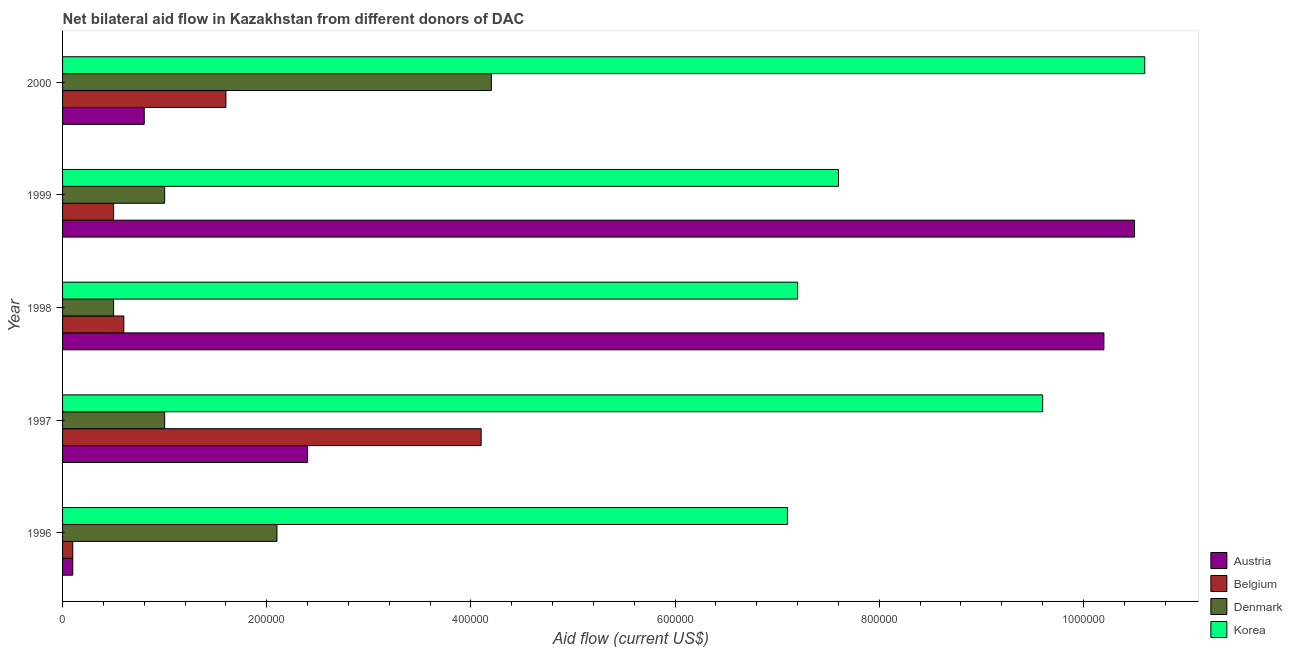How many groups of bars are there?
Offer a terse response. 5. In how many cases, is the number of bars for a given year not equal to the number of legend labels?
Offer a terse response. 0. What is the amount of aid given by denmark in 1996?
Offer a very short reply. 2.10e+05. Across all years, what is the maximum amount of aid given by denmark?
Make the answer very short. 4.20e+05. Across all years, what is the minimum amount of aid given by korea?
Your answer should be very brief. 7.10e+05. In which year was the amount of aid given by denmark maximum?
Provide a succinct answer. 2000. What is the total amount of aid given by austria in the graph?
Provide a succinct answer. 2.40e+06. What is the difference between the amount of aid given by austria in 1996 and that in 1997?
Give a very brief answer. -2.30e+05. What is the difference between the amount of aid given by denmark in 1997 and the amount of aid given by belgium in 2000?
Give a very brief answer. -6.00e+04. What is the average amount of aid given by belgium per year?
Provide a short and direct response. 1.38e+05. In the year 1998, what is the difference between the amount of aid given by denmark and amount of aid given by korea?
Ensure brevity in your answer.  -6.70e+05. What is the ratio of the amount of aid given by denmark in 1996 to that in 1999?
Your response must be concise. 2.1. Is the difference between the amount of aid given by belgium in 1997 and 2000 greater than the difference between the amount of aid given by korea in 1997 and 2000?
Keep it short and to the point. Yes. What is the difference between the highest and the lowest amount of aid given by belgium?
Your answer should be very brief. 4.00e+05. In how many years, is the amount of aid given by korea greater than the average amount of aid given by korea taken over all years?
Provide a short and direct response. 2. Is the sum of the amount of aid given by belgium in 1996 and 1999 greater than the maximum amount of aid given by denmark across all years?
Make the answer very short. No. What does the 2nd bar from the top in 1997 represents?
Make the answer very short. Denmark. What does the 4th bar from the bottom in 1999 represents?
Your response must be concise. Korea. How many years are there in the graph?
Offer a very short reply. 5. Are the values on the major ticks of X-axis written in scientific E-notation?
Offer a very short reply. No. Where does the legend appear in the graph?
Your answer should be very brief. Bottom right. How are the legend labels stacked?
Your answer should be very brief. Vertical. What is the title of the graph?
Keep it short and to the point. Net bilateral aid flow in Kazakhstan from different donors of DAC. Does "UNHCR" appear as one of the legend labels in the graph?
Your response must be concise. No. What is the Aid flow (current US$) in Denmark in 1996?
Keep it short and to the point. 2.10e+05. What is the Aid flow (current US$) in Korea in 1996?
Your response must be concise. 7.10e+05. What is the Aid flow (current US$) in Austria in 1997?
Provide a short and direct response. 2.40e+05. What is the Aid flow (current US$) of Denmark in 1997?
Offer a very short reply. 1.00e+05. What is the Aid flow (current US$) of Korea in 1997?
Make the answer very short. 9.60e+05. What is the Aid flow (current US$) in Austria in 1998?
Provide a short and direct response. 1.02e+06. What is the Aid flow (current US$) of Belgium in 1998?
Keep it short and to the point. 6.00e+04. What is the Aid flow (current US$) of Denmark in 1998?
Make the answer very short. 5.00e+04. What is the Aid flow (current US$) in Korea in 1998?
Your response must be concise. 7.20e+05. What is the Aid flow (current US$) of Austria in 1999?
Give a very brief answer. 1.05e+06. What is the Aid flow (current US$) of Belgium in 1999?
Make the answer very short. 5.00e+04. What is the Aid flow (current US$) of Korea in 1999?
Provide a short and direct response. 7.60e+05. What is the Aid flow (current US$) in Austria in 2000?
Your response must be concise. 8.00e+04. What is the Aid flow (current US$) of Denmark in 2000?
Provide a short and direct response. 4.20e+05. What is the Aid flow (current US$) in Korea in 2000?
Offer a very short reply. 1.06e+06. Across all years, what is the maximum Aid flow (current US$) of Austria?
Your answer should be very brief. 1.05e+06. Across all years, what is the maximum Aid flow (current US$) in Denmark?
Provide a short and direct response. 4.20e+05. Across all years, what is the maximum Aid flow (current US$) of Korea?
Your response must be concise. 1.06e+06. Across all years, what is the minimum Aid flow (current US$) of Denmark?
Ensure brevity in your answer.  5.00e+04. Across all years, what is the minimum Aid flow (current US$) in Korea?
Give a very brief answer. 7.10e+05. What is the total Aid flow (current US$) in Austria in the graph?
Provide a short and direct response. 2.40e+06. What is the total Aid flow (current US$) of Belgium in the graph?
Offer a terse response. 6.90e+05. What is the total Aid flow (current US$) of Denmark in the graph?
Keep it short and to the point. 8.80e+05. What is the total Aid flow (current US$) in Korea in the graph?
Keep it short and to the point. 4.21e+06. What is the difference between the Aid flow (current US$) of Belgium in 1996 and that in 1997?
Provide a succinct answer. -4.00e+05. What is the difference between the Aid flow (current US$) of Denmark in 1996 and that in 1997?
Your answer should be compact. 1.10e+05. What is the difference between the Aid flow (current US$) in Korea in 1996 and that in 1997?
Give a very brief answer. -2.50e+05. What is the difference between the Aid flow (current US$) of Austria in 1996 and that in 1998?
Make the answer very short. -1.01e+06. What is the difference between the Aid flow (current US$) of Belgium in 1996 and that in 1998?
Your response must be concise. -5.00e+04. What is the difference between the Aid flow (current US$) of Korea in 1996 and that in 1998?
Provide a succinct answer. -10000. What is the difference between the Aid flow (current US$) of Austria in 1996 and that in 1999?
Ensure brevity in your answer.  -1.04e+06. What is the difference between the Aid flow (current US$) in Belgium in 1996 and that in 1999?
Your answer should be compact. -4.00e+04. What is the difference between the Aid flow (current US$) in Korea in 1996 and that in 1999?
Give a very brief answer. -5.00e+04. What is the difference between the Aid flow (current US$) in Denmark in 1996 and that in 2000?
Give a very brief answer. -2.10e+05. What is the difference between the Aid flow (current US$) of Korea in 1996 and that in 2000?
Keep it short and to the point. -3.50e+05. What is the difference between the Aid flow (current US$) of Austria in 1997 and that in 1998?
Ensure brevity in your answer.  -7.80e+05. What is the difference between the Aid flow (current US$) of Belgium in 1997 and that in 1998?
Make the answer very short. 3.50e+05. What is the difference between the Aid flow (current US$) of Denmark in 1997 and that in 1998?
Keep it short and to the point. 5.00e+04. What is the difference between the Aid flow (current US$) of Austria in 1997 and that in 1999?
Your answer should be very brief. -8.10e+05. What is the difference between the Aid flow (current US$) in Belgium in 1997 and that in 1999?
Provide a succinct answer. 3.60e+05. What is the difference between the Aid flow (current US$) of Denmark in 1997 and that in 1999?
Give a very brief answer. 0. What is the difference between the Aid flow (current US$) in Korea in 1997 and that in 1999?
Give a very brief answer. 2.00e+05. What is the difference between the Aid flow (current US$) of Belgium in 1997 and that in 2000?
Your answer should be compact. 2.50e+05. What is the difference between the Aid flow (current US$) of Denmark in 1997 and that in 2000?
Your answer should be very brief. -3.20e+05. What is the difference between the Aid flow (current US$) in Korea in 1997 and that in 2000?
Keep it short and to the point. -1.00e+05. What is the difference between the Aid flow (current US$) in Korea in 1998 and that in 1999?
Ensure brevity in your answer.  -4.00e+04. What is the difference between the Aid flow (current US$) of Austria in 1998 and that in 2000?
Offer a very short reply. 9.40e+05. What is the difference between the Aid flow (current US$) in Belgium in 1998 and that in 2000?
Your answer should be compact. -1.00e+05. What is the difference between the Aid flow (current US$) in Denmark in 1998 and that in 2000?
Your response must be concise. -3.70e+05. What is the difference between the Aid flow (current US$) in Austria in 1999 and that in 2000?
Your answer should be compact. 9.70e+05. What is the difference between the Aid flow (current US$) in Denmark in 1999 and that in 2000?
Your response must be concise. -3.20e+05. What is the difference between the Aid flow (current US$) in Austria in 1996 and the Aid flow (current US$) in Belgium in 1997?
Your answer should be compact. -4.00e+05. What is the difference between the Aid flow (current US$) of Austria in 1996 and the Aid flow (current US$) of Korea in 1997?
Offer a very short reply. -9.50e+05. What is the difference between the Aid flow (current US$) in Belgium in 1996 and the Aid flow (current US$) in Denmark in 1997?
Offer a terse response. -9.00e+04. What is the difference between the Aid flow (current US$) in Belgium in 1996 and the Aid flow (current US$) in Korea in 1997?
Ensure brevity in your answer.  -9.50e+05. What is the difference between the Aid flow (current US$) in Denmark in 1996 and the Aid flow (current US$) in Korea in 1997?
Your response must be concise. -7.50e+05. What is the difference between the Aid flow (current US$) in Austria in 1996 and the Aid flow (current US$) in Korea in 1998?
Your answer should be very brief. -7.10e+05. What is the difference between the Aid flow (current US$) in Belgium in 1996 and the Aid flow (current US$) in Denmark in 1998?
Make the answer very short. -4.00e+04. What is the difference between the Aid flow (current US$) in Belgium in 1996 and the Aid flow (current US$) in Korea in 1998?
Offer a terse response. -7.10e+05. What is the difference between the Aid flow (current US$) in Denmark in 1996 and the Aid flow (current US$) in Korea in 1998?
Offer a terse response. -5.10e+05. What is the difference between the Aid flow (current US$) in Austria in 1996 and the Aid flow (current US$) in Korea in 1999?
Your answer should be compact. -7.50e+05. What is the difference between the Aid flow (current US$) in Belgium in 1996 and the Aid flow (current US$) in Denmark in 1999?
Provide a succinct answer. -9.00e+04. What is the difference between the Aid flow (current US$) of Belgium in 1996 and the Aid flow (current US$) of Korea in 1999?
Your response must be concise. -7.50e+05. What is the difference between the Aid flow (current US$) of Denmark in 1996 and the Aid flow (current US$) of Korea in 1999?
Ensure brevity in your answer.  -5.50e+05. What is the difference between the Aid flow (current US$) in Austria in 1996 and the Aid flow (current US$) in Belgium in 2000?
Provide a succinct answer. -1.50e+05. What is the difference between the Aid flow (current US$) of Austria in 1996 and the Aid flow (current US$) of Denmark in 2000?
Offer a very short reply. -4.10e+05. What is the difference between the Aid flow (current US$) in Austria in 1996 and the Aid flow (current US$) in Korea in 2000?
Your answer should be compact. -1.05e+06. What is the difference between the Aid flow (current US$) in Belgium in 1996 and the Aid flow (current US$) in Denmark in 2000?
Make the answer very short. -4.10e+05. What is the difference between the Aid flow (current US$) in Belgium in 1996 and the Aid flow (current US$) in Korea in 2000?
Keep it short and to the point. -1.05e+06. What is the difference between the Aid flow (current US$) of Denmark in 1996 and the Aid flow (current US$) of Korea in 2000?
Keep it short and to the point. -8.50e+05. What is the difference between the Aid flow (current US$) of Austria in 1997 and the Aid flow (current US$) of Belgium in 1998?
Offer a terse response. 1.80e+05. What is the difference between the Aid flow (current US$) of Austria in 1997 and the Aid flow (current US$) of Korea in 1998?
Provide a succinct answer. -4.80e+05. What is the difference between the Aid flow (current US$) in Belgium in 1997 and the Aid flow (current US$) in Korea in 1998?
Your response must be concise. -3.10e+05. What is the difference between the Aid flow (current US$) in Denmark in 1997 and the Aid flow (current US$) in Korea in 1998?
Ensure brevity in your answer.  -6.20e+05. What is the difference between the Aid flow (current US$) of Austria in 1997 and the Aid flow (current US$) of Korea in 1999?
Keep it short and to the point. -5.20e+05. What is the difference between the Aid flow (current US$) in Belgium in 1997 and the Aid flow (current US$) in Denmark in 1999?
Your answer should be very brief. 3.10e+05. What is the difference between the Aid flow (current US$) of Belgium in 1997 and the Aid flow (current US$) of Korea in 1999?
Keep it short and to the point. -3.50e+05. What is the difference between the Aid flow (current US$) of Denmark in 1997 and the Aid flow (current US$) of Korea in 1999?
Offer a terse response. -6.60e+05. What is the difference between the Aid flow (current US$) of Austria in 1997 and the Aid flow (current US$) of Belgium in 2000?
Offer a terse response. 8.00e+04. What is the difference between the Aid flow (current US$) in Austria in 1997 and the Aid flow (current US$) in Denmark in 2000?
Your response must be concise. -1.80e+05. What is the difference between the Aid flow (current US$) in Austria in 1997 and the Aid flow (current US$) in Korea in 2000?
Keep it short and to the point. -8.20e+05. What is the difference between the Aid flow (current US$) of Belgium in 1997 and the Aid flow (current US$) of Denmark in 2000?
Your answer should be compact. -10000. What is the difference between the Aid flow (current US$) of Belgium in 1997 and the Aid flow (current US$) of Korea in 2000?
Keep it short and to the point. -6.50e+05. What is the difference between the Aid flow (current US$) of Denmark in 1997 and the Aid flow (current US$) of Korea in 2000?
Your answer should be very brief. -9.60e+05. What is the difference between the Aid flow (current US$) of Austria in 1998 and the Aid flow (current US$) of Belgium in 1999?
Provide a succinct answer. 9.70e+05. What is the difference between the Aid flow (current US$) in Austria in 1998 and the Aid flow (current US$) in Denmark in 1999?
Offer a terse response. 9.20e+05. What is the difference between the Aid flow (current US$) of Austria in 1998 and the Aid flow (current US$) of Korea in 1999?
Keep it short and to the point. 2.60e+05. What is the difference between the Aid flow (current US$) of Belgium in 1998 and the Aid flow (current US$) of Denmark in 1999?
Make the answer very short. -4.00e+04. What is the difference between the Aid flow (current US$) in Belgium in 1998 and the Aid flow (current US$) in Korea in 1999?
Keep it short and to the point. -7.00e+05. What is the difference between the Aid flow (current US$) of Denmark in 1998 and the Aid flow (current US$) of Korea in 1999?
Give a very brief answer. -7.10e+05. What is the difference between the Aid flow (current US$) in Austria in 1998 and the Aid flow (current US$) in Belgium in 2000?
Your answer should be compact. 8.60e+05. What is the difference between the Aid flow (current US$) in Austria in 1998 and the Aid flow (current US$) in Denmark in 2000?
Keep it short and to the point. 6.00e+05. What is the difference between the Aid flow (current US$) in Austria in 1998 and the Aid flow (current US$) in Korea in 2000?
Your response must be concise. -4.00e+04. What is the difference between the Aid flow (current US$) of Belgium in 1998 and the Aid flow (current US$) of Denmark in 2000?
Make the answer very short. -3.60e+05. What is the difference between the Aid flow (current US$) of Belgium in 1998 and the Aid flow (current US$) of Korea in 2000?
Offer a very short reply. -1.00e+06. What is the difference between the Aid flow (current US$) of Denmark in 1998 and the Aid flow (current US$) of Korea in 2000?
Give a very brief answer. -1.01e+06. What is the difference between the Aid flow (current US$) of Austria in 1999 and the Aid flow (current US$) of Belgium in 2000?
Make the answer very short. 8.90e+05. What is the difference between the Aid flow (current US$) in Austria in 1999 and the Aid flow (current US$) in Denmark in 2000?
Ensure brevity in your answer.  6.30e+05. What is the difference between the Aid flow (current US$) of Austria in 1999 and the Aid flow (current US$) of Korea in 2000?
Your answer should be very brief. -10000. What is the difference between the Aid flow (current US$) in Belgium in 1999 and the Aid flow (current US$) in Denmark in 2000?
Your answer should be compact. -3.70e+05. What is the difference between the Aid flow (current US$) in Belgium in 1999 and the Aid flow (current US$) in Korea in 2000?
Make the answer very short. -1.01e+06. What is the difference between the Aid flow (current US$) of Denmark in 1999 and the Aid flow (current US$) of Korea in 2000?
Make the answer very short. -9.60e+05. What is the average Aid flow (current US$) of Austria per year?
Your response must be concise. 4.80e+05. What is the average Aid flow (current US$) of Belgium per year?
Keep it short and to the point. 1.38e+05. What is the average Aid flow (current US$) of Denmark per year?
Keep it short and to the point. 1.76e+05. What is the average Aid flow (current US$) of Korea per year?
Your response must be concise. 8.42e+05. In the year 1996, what is the difference between the Aid flow (current US$) of Austria and Aid flow (current US$) of Belgium?
Offer a very short reply. 0. In the year 1996, what is the difference between the Aid flow (current US$) in Austria and Aid flow (current US$) in Denmark?
Your response must be concise. -2.00e+05. In the year 1996, what is the difference between the Aid flow (current US$) of Austria and Aid flow (current US$) of Korea?
Make the answer very short. -7.00e+05. In the year 1996, what is the difference between the Aid flow (current US$) of Belgium and Aid flow (current US$) of Korea?
Your answer should be very brief. -7.00e+05. In the year 1996, what is the difference between the Aid flow (current US$) of Denmark and Aid flow (current US$) of Korea?
Your response must be concise. -5.00e+05. In the year 1997, what is the difference between the Aid flow (current US$) in Austria and Aid flow (current US$) in Belgium?
Make the answer very short. -1.70e+05. In the year 1997, what is the difference between the Aid flow (current US$) in Austria and Aid flow (current US$) in Denmark?
Give a very brief answer. 1.40e+05. In the year 1997, what is the difference between the Aid flow (current US$) in Austria and Aid flow (current US$) in Korea?
Offer a very short reply. -7.20e+05. In the year 1997, what is the difference between the Aid flow (current US$) of Belgium and Aid flow (current US$) of Korea?
Make the answer very short. -5.50e+05. In the year 1997, what is the difference between the Aid flow (current US$) in Denmark and Aid flow (current US$) in Korea?
Your answer should be compact. -8.60e+05. In the year 1998, what is the difference between the Aid flow (current US$) of Austria and Aid flow (current US$) of Belgium?
Ensure brevity in your answer.  9.60e+05. In the year 1998, what is the difference between the Aid flow (current US$) of Austria and Aid flow (current US$) of Denmark?
Keep it short and to the point. 9.70e+05. In the year 1998, what is the difference between the Aid flow (current US$) of Belgium and Aid flow (current US$) of Korea?
Make the answer very short. -6.60e+05. In the year 1998, what is the difference between the Aid flow (current US$) of Denmark and Aid flow (current US$) of Korea?
Provide a short and direct response. -6.70e+05. In the year 1999, what is the difference between the Aid flow (current US$) in Austria and Aid flow (current US$) in Denmark?
Provide a short and direct response. 9.50e+05. In the year 1999, what is the difference between the Aid flow (current US$) of Austria and Aid flow (current US$) of Korea?
Your answer should be compact. 2.90e+05. In the year 1999, what is the difference between the Aid flow (current US$) of Belgium and Aid flow (current US$) of Korea?
Make the answer very short. -7.10e+05. In the year 1999, what is the difference between the Aid flow (current US$) in Denmark and Aid flow (current US$) in Korea?
Your answer should be compact. -6.60e+05. In the year 2000, what is the difference between the Aid flow (current US$) of Austria and Aid flow (current US$) of Korea?
Offer a very short reply. -9.80e+05. In the year 2000, what is the difference between the Aid flow (current US$) of Belgium and Aid flow (current US$) of Korea?
Keep it short and to the point. -9.00e+05. In the year 2000, what is the difference between the Aid flow (current US$) of Denmark and Aid flow (current US$) of Korea?
Offer a very short reply. -6.40e+05. What is the ratio of the Aid flow (current US$) in Austria in 1996 to that in 1997?
Your answer should be very brief. 0.04. What is the ratio of the Aid flow (current US$) in Belgium in 1996 to that in 1997?
Your answer should be very brief. 0.02. What is the ratio of the Aid flow (current US$) of Denmark in 1996 to that in 1997?
Your response must be concise. 2.1. What is the ratio of the Aid flow (current US$) in Korea in 1996 to that in 1997?
Offer a very short reply. 0.74. What is the ratio of the Aid flow (current US$) of Austria in 1996 to that in 1998?
Your answer should be very brief. 0.01. What is the ratio of the Aid flow (current US$) in Korea in 1996 to that in 1998?
Provide a short and direct response. 0.99. What is the ratio of the Aid flow (current US$) in Austria in 1996 to that in 1999?
Provide a succinct answer. 0.01. What is the ratio of the Aid flow (current US$) in Belgium in 1996 to that in 1999?
Your response must be concise. 0.2. What is the ratio of the Aid flow (current US$) of Korea in 1996 to that in 1999?
Provide a succinct answer. 0.93. What is the ratio of the Aid flow (current US$) in Austria in 1996 to that in 2000?
Your response must be concise. 0.12. What is the ratio of the Aid flow (current US$) of Belgium in 1996 to that in 2000?
Ensure brevity in your answer.  0.06. What is the ratio of the Aid flow (current US$) of Denmark in 1996 to that in 2000?
Ensure brevity in your answer.  0.5. What is the ratio of the Aid flow (current US$) in Korea in 1996 to that in 2000?
Provide a short and direct response. 0.67. What is the ratio of the Aid flow (current US$) of Austria in 1997 to that in 1998?
Your answer should be compact. 0.24. What is the ratio of the Aid flow (current US$) in Belgium in 1997 to that in 1998?
Keep it short and to the point. 6.83. What is the ratio of the Aid flow (current US$) in Korea in 1997 to that in 1998?
Make the answer very short. 1.33. What is the ratio of the Aid flow (current US$) in Austria in 1997 to that in 1999?
Offer a terse response. 0.23. What is the ratio of the Aid flow (current US$) of Korea in 1997 to that in 1999?
Provide a short and direct response. 1.26. What is the ratio of the Aid flow (current US$) in Austria in 1997 to that in 2000?
Your answer should be very brief. 3. What is the ratio of the Aid flow (current US$) in Belgium in 1997 to that in 2000?
Your answer should be compact. 2.56. What is the ratio of the Aid flow (current US$) in Denmark in 1997 to that in 2000?
Provide a succinct answer. 0.24. What is the ratio of the Aid flow (current US$) in Korea in 1997 to that in 2000?
Ensure brevity in your answer.  0.91. What is the ratio of the Aid flow (current US$) of Austria in 1998 to that in 1999?
Your answer should be very brief. 0.97. What is the ratio of the Aid flow (current US$) in Belgium in 1998 to that in 1999?
Keep it short and to the point. 1.2. What is the ratio of the Aid flow (current US$) in Denmark in 1998 to that in 1999?
Provide a short and direct response. 0.5. What is the ratio of the Aid flow (current US$) of Austria in 1998 to that in 2000?
Give a very brief answer. 12.75. What is the ratio of the Aid flow (current US$) of Denmark in 1998 to that in 2000?
Your response must be concise. 0.12. What is the ratio of the Aid flow (current US$) of Korea in 1998 to that in 2000?
Your answer should be compact. 0.68. What is the ratio of the Aid flow (current US$) of Austria in 1999 to that in 2000?
Give a very brief answer. 13.12. What is the ratio of the Aid flow (current US$) of Belgium in 1999 to that in 2000?
Your answer should be compact. 0.31. What is the ratio of the Aid flow (current US$) in Denmark in 1999 to that in 2000?
Your response must be concise. 0.24. What is the ratio of the Aid flow (current US$) of Korea in 1999 to that in 2000?
Your answer should be very brief. 0.72. What is the difference between the highest and the second highest Aid flow (current US$) of Belgium?
Ensure brevity in your answer.  2.50e+05. What is the difference between the highest and the second highest Aid flow (current US$) of Korea?
Your answer should be very brief. 1.00e+05. What is the difference between the highest and the lowest Aid flow (current US$) in Austria?
Give a very brief answer. 1.04e+06. 